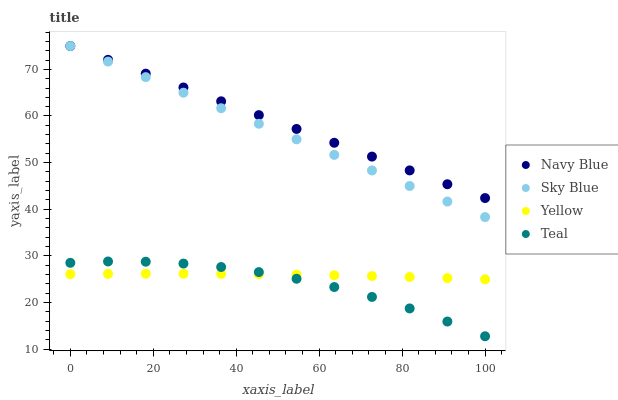Does Teal have the minimum area under the curve?
Answer yes or no. Yes. Does Navy Blue have the maximum area under the curve?
Answer yes or no. Yes. Does Yellow have the minimum area under the curve?
Answer yes or no. No. Does Yellow have the maximum area under the curve?
Answer yes or no. No. Is Sky Blue the smoothest?
Answer yes or no. Yes. Is Teal the roughest?
Answer yes or no. Yes. Is Yellow the smoothest?
Answer yes or no. No. Is Yellow the roughest?
Answer yes or no. No. Does Teal have the lowest value?
Answer yes or no. Yes. Does Yellow have the lowest value?
Answer yes or no. No. Does Sky Blue have the highest value?
Answer yes or no. Yes. Does Teal have the highest value?
Answer yes or no. No. Is Yellow less than Navy Blue?
Answer yes or no. Yes. Is Navy Blue greater than Teal?
Answer yes or no. Yes. Does Teal intersect Yellow?
Answer yes or no. Yes. Is Teal less than Yellow?
Answer yes or no. No. Is Teal greater than Yellow?
Answer yes or no. No. Does Yellow intersect Navy Blue?
Answer yes or no. No. 